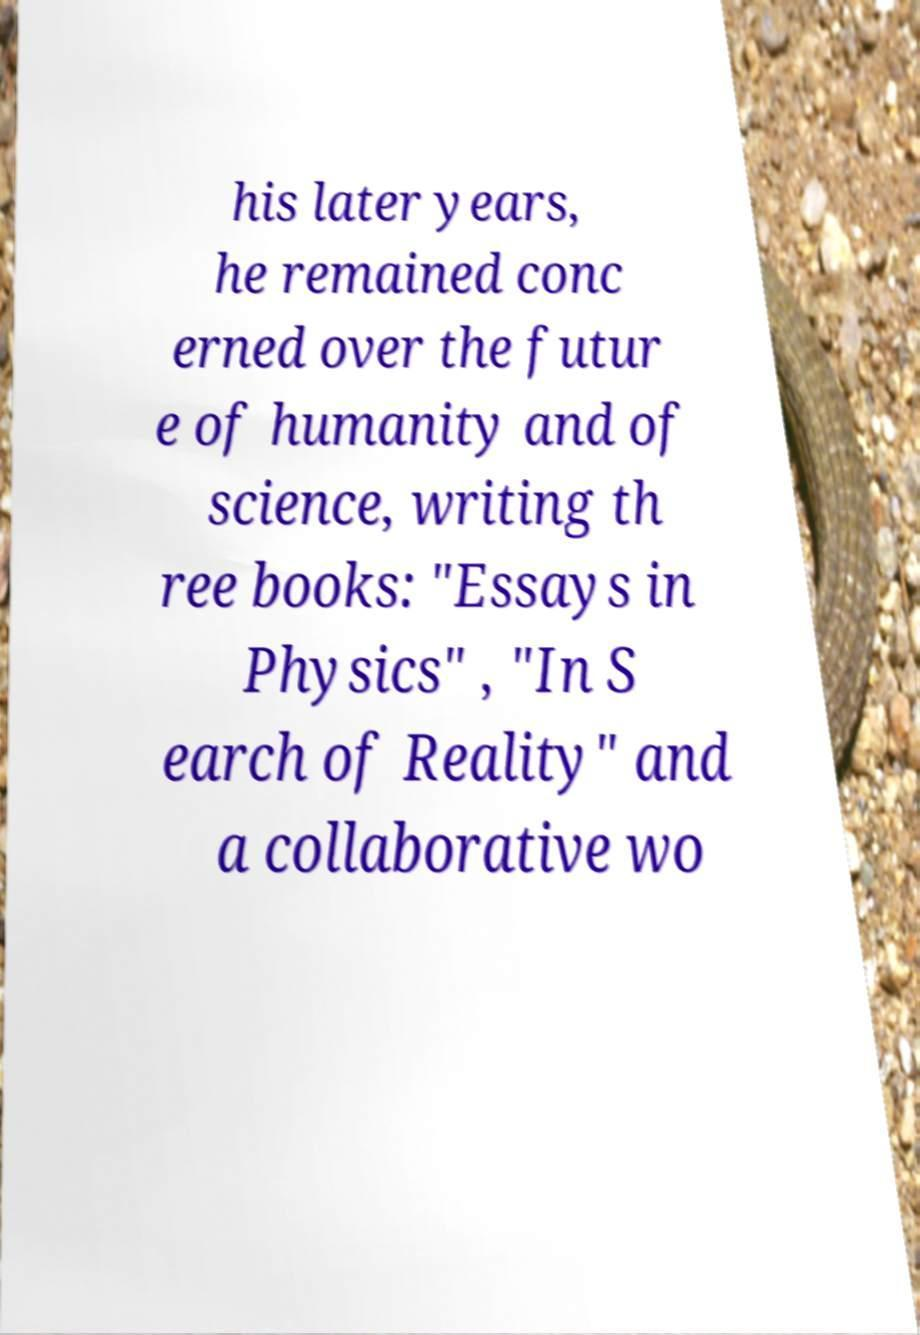Please identify and transcribe the text found in this image. his later years, he remained conc erned over the futur e of humanity and of science, writing th ree books: "Essays in Physics" , "In S earch of Reality" and a collaborative wo 